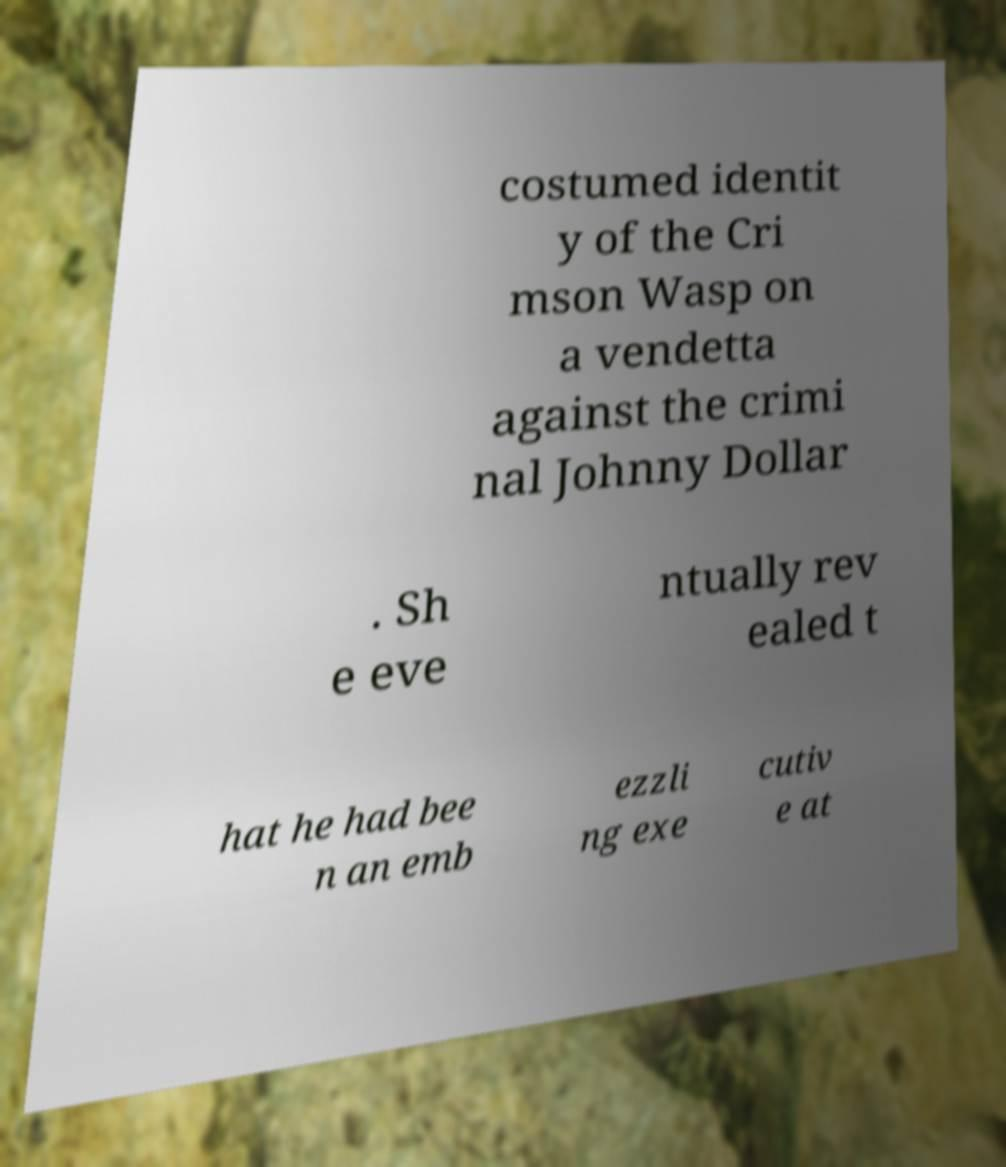Can you accurately transcribe the text from the provided image for me? costumed identit y of the Cri mson Wasp on a vendetta against the crimi nal Johnny Dollar . Sh e eve ntually rev ealed t hat he had bee n an emb ezzli ng exe cutiv e at 